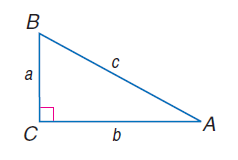Answer the mathemtical geometry problem and directly provide the correct option letter.
Question: a = 8, b = 15, and c = 17, find \tan A.
Choices: A: 0.33 B: 0.47 C: 0.53 D: 0.57 C 